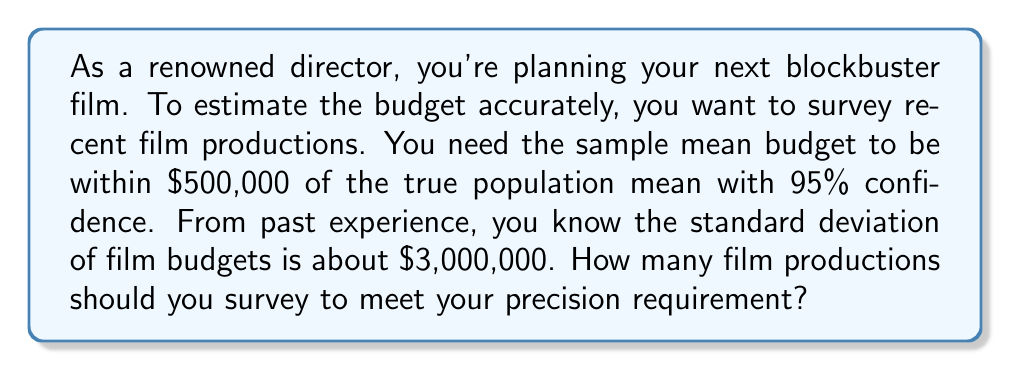Could you help me with this problem? Let's approach this step-by-step:

1) We're dealing with a confidence interval for the mean. The formula for the margin of error (E) is:

   $E = z_{\alpha/2} \cdot \frac{\sigma}{\sqrt{n}}$

   Where:
   - $z_{\alpha/2}$ is the critical value for the desired confidence level
   - $\sigma$ is the population standard deviation
   - $n$ is the sample size

2) We're given:
   - Confidence level = 95%, so $z_{\alpha/2} = 1.96$
   - Margin of error (E) = $500,000
   - $\sigma = $3,000,000

3) Let's substitute these into our formula:

   $500,000 = 1.96 \cdot \frac{3,000,000}{\sqrt{n}}$

4) Now, let's solve for n:

   $\sqrt{n} = \frac{1.96 \cdot 3,000,000}{500,000}$

   $\sqrt{n} = 11.76$

   $n = (11.76)^2 = 138.2976$

5) Since n must be a whole number, we round up to ensure we meet or exceed the precision requirement.

   $n = 139$

Therefore, you should survey at least 139 recent film productions to estimate the budget with the desired precision.
Answer: 139 film productions 